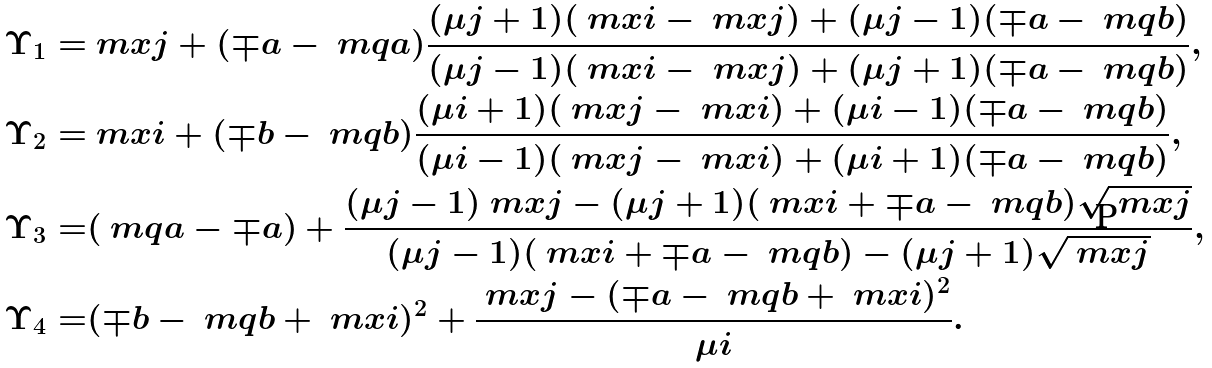<formula> <loc_0><loc_0><loc_500><loc_500>\Upsilon _ { 1 } = & \ m x j + ( \mp a - \ m q a ) \frac { ( \mu j + 1 ) ( \ m x i - \ m x j ) + ( \mu j - 1 ) ( \mp a - \ m q b ) } { ( \mu j - 1 ) ( \ m x i - \ m x j ) + ( \mu j + 1 ) ( \mp a - \ m q b ) } , \\ \Upsilon _ { 2 } = & \ m x i + ( \mp b - \ m q b ) \frac { ( \mu i + 1 ) ( \ m x j - \ m x i ) + ( \mu i - 1 ) ( \mp a - \ m q b ) } { ( \mu i - 1 ) ( \ m x j - \ m x i ) + ( \mu i + 1 ) ( \mp a - \ m q b ) } , \\ \Upsilon _ { 3 } = & ( \ m q a - \mp a ) + \frac { ( \mu j - 1 ) \ m x j - ( \mu j + 1 ) ( \ m x i + \mp a - \ m q b ) \sqrt { \ m x j } } { ( \mu j - 1 ) ( \ m x i + \mp a - \ m q b ) - ( \mu j + 1 ) \sqrt { \ m x j } } , \\ \Upsilon _ { 4 } = & ( \mp b - \ m q b + \ m x i ) ^ { 2 } + \frac { \ m x j - ( \mp a - \ m q b + \ m x i ) ^ { 2 } } { \mu i } .</formula> 